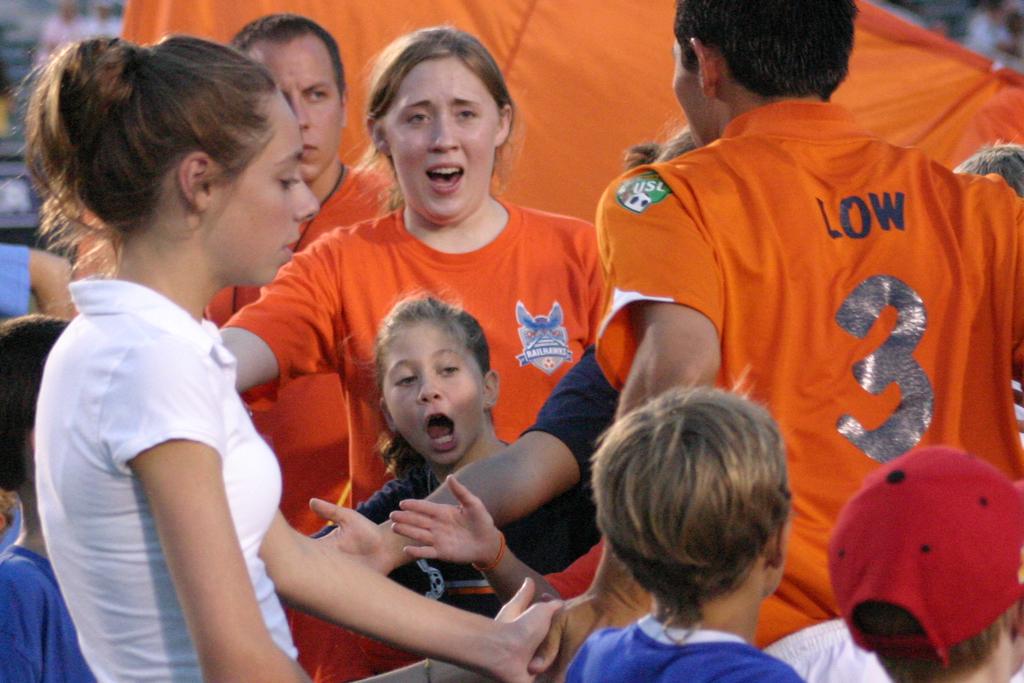What´s the team color?
Make the answer very short. Orange. 